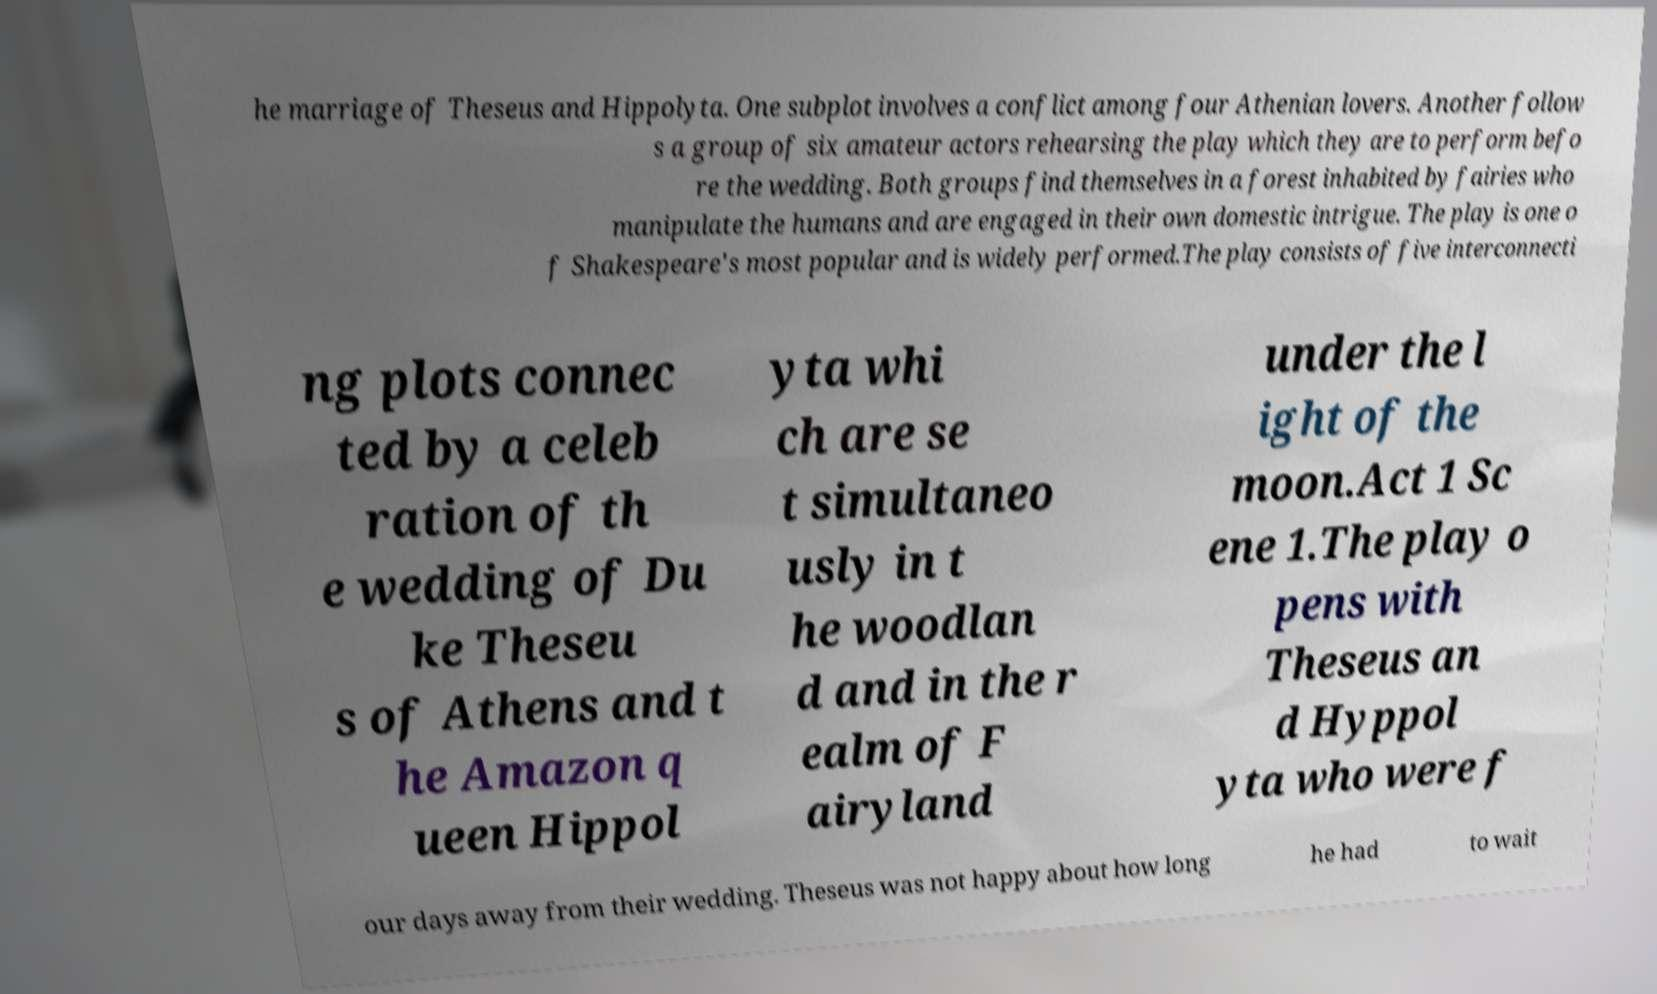Can you accurately transcribe the text from the provided image for me? he marriage of Theseus and Hippolyta. One subplot involves a conflict among four Athenian lovers. Another follow s a group of six amateur actors rehearsing the play which they are to perform befo re the wedding. Both groups find themselves in a forest inhabited by fairies who manipulate the humans and are engaged in their own domestic intrigue. The play is one o f Shakespeare's most popular and is widely performed.The play consists of five interconnecti ng plots connec ted by a celeb ration of th e wedding of Du ke Theseu s of Athens and t he Amazon q ueen Hippol yta whi ch are se t simultaneo usly in t he woodlan d and in the r ealm of F airyland under the l ight of the moon.Act 1 Sc ene 1.The play o pens with Theseus an d Hyppol yta who were f our days away from their wedding. Theseus was not happy about how long he had to wait 